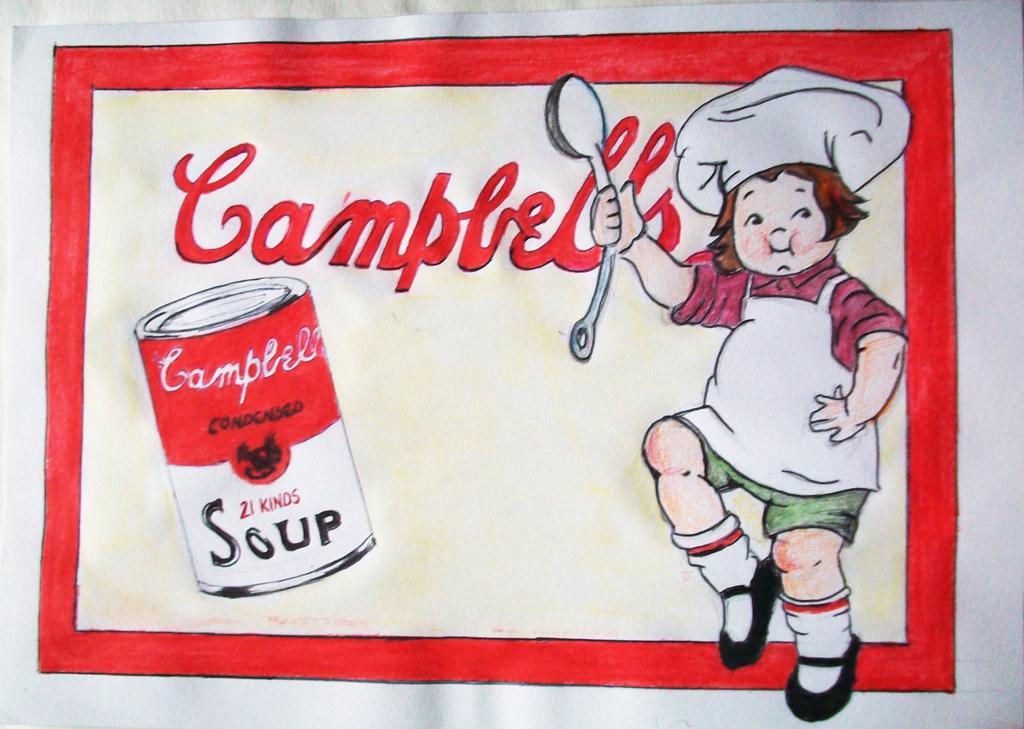Describe this image in one or two sentences. In this image, I can see a poster with the pictures of a person holding a spoon, tin and the letters written on the poster. 